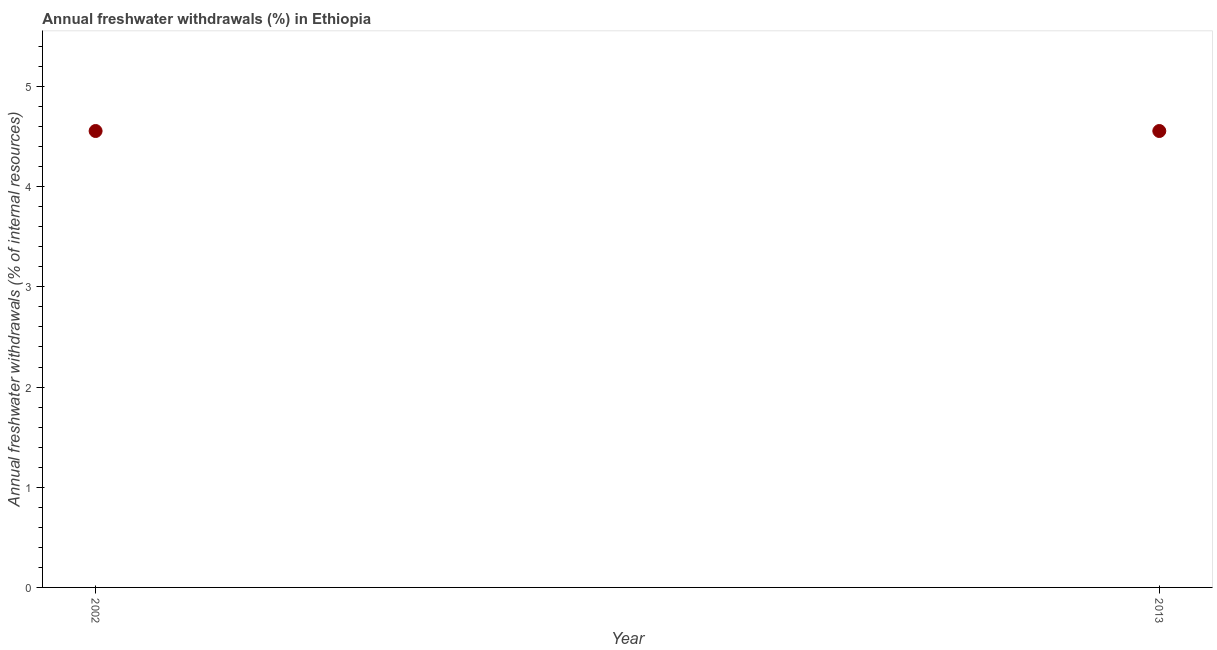What is the annual freshwater withdrawals in 2002?
Your response must be concise. 4.56. Across all years, what is the maximum annual freshwater withdrawals?
Provide a succinct answer. 4.56. Across all years, what is the minimum annual freshwater withdrawals?
Ensure brevity in your answer.  4.56. In which year was the annual freshwater withdrawals maximum?
Your answer should be very brief. 2002. In which year was the annual freshwater withdrawals minimum?
Your answer should be compact. 2002. What is the sum of the annual freshwater withdrawals?
Provide a short and direct response. 9.11. What is the average annual freshwater withdrawals per year?
Your answer should be compact. 4.56. What is the median annual freshwater withdrawals?
Ensure brevity in your answer.  4.56. What is the ratio of the annual freshwater withdrawals in 2002 to that in 2013?
Ensure brevity in your answer.  1. In how many years, is the annual freshwater withdrawals greater than the average annual freshwater withdrawals taken over all years?
Ensure brevity in your answer.  0. What is the difference between two consecutive major ticks on the Y-axis?
Offer a terse response. 1. Does the graph contain any zero values?
Make the answer very short. No. What is the title of the graph?
Ensure brevity in your answer.  Annual freshwater withdrawals (%) in Ethiopia. What is the label or title of the Y-axis?
Make the answer very short. Annual freshwater withdrawals (% of internal resources). What is the Annual freshwater withdrawals (% of internal resources) in 2002?
Ensure brevity in your answer.  4.56. What is the Annual freshwater withdrawals (% of internal resources) in 2013?
Offer a very short reply. 4.56. What is the difference between the Annual freshwater withdrawals (% of internal resources) in 2002 and 2013?
Ensure brevity in your answer.  0. 